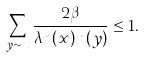Convert formula to latex. <formula><loc_0><loc_0><loc_500><loc_500>\sum _ { y \sim x } \frac { 2 \beta } { \lambda n ( x ) n ( y ) } \leq 1 .</formula> 